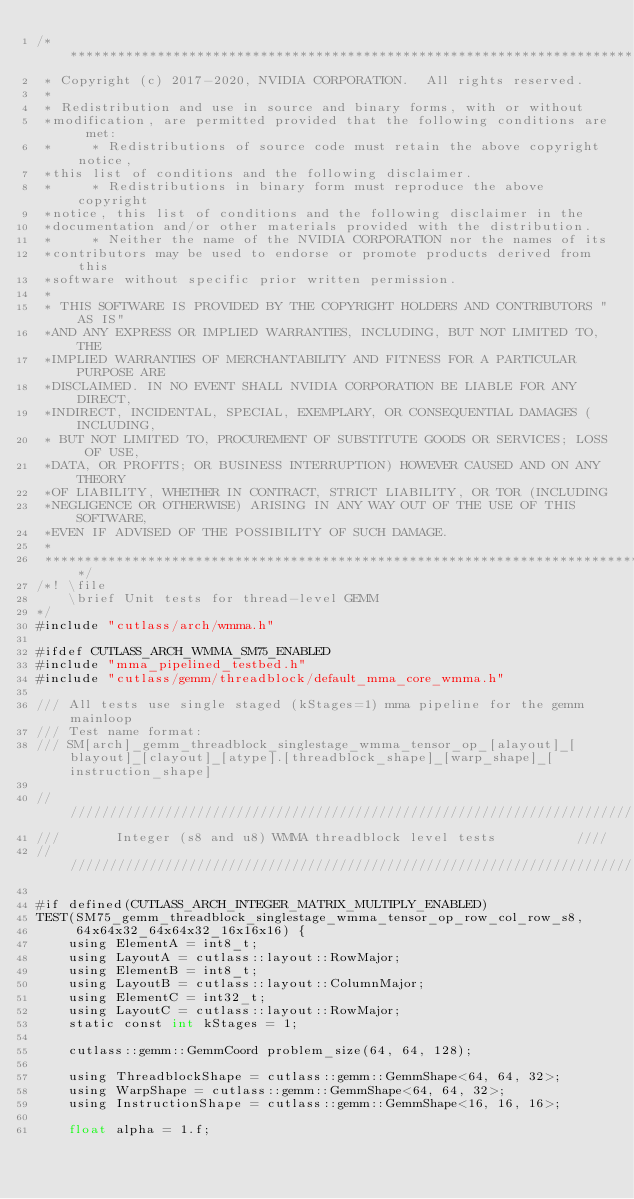Convert code to text. <code><loc_0><loc_0><loc_500><loc_500><_Cuda_>/***************************************************************************************************
 * Copyright (c) 2017-2020, NVIDIA CORPORATION.  All rights reserved.
 *
 * Redistribution and use in source and binary forms, with or without
 *modification, are permitted provided that the following conditions are met:
 *     * Redistributions of source code must retain the above copyright notice,
 *this list of conditions and the following disclaimer.
 *     * Redistributions in binary form must reproduce the above copyright
 *notice, this list of conditions and the following disclaimer in the
 *documentation and/or other materials provided with the distribution.
 *     * Neither the name of the NVIDIA CORPORATION nor the names of its
 *contributors may be used to endorse or promote products derived from this
 *software without specific prior written permission.
 *
 * THIS SOFTWARE IS PROVIDED BY THE COPYRIGHT HOLDERS AND CONTRIBUTORS "AS IS"
 *AND ANY EXPRESS OR IMPLIED WARRANTIES, INCLUDING, BUT NOT LIMITED TO, THE
 *IMPLIED WARRANTIES OF MERCHANTABILITY AND FITNESS FOR A PARTICULAR PURPOSE ARE
 *DISCLAIMED. IN NO EVENT SHALL NVIDIA CORPORATION BE LIABLE FOR ANY DIRECT,
 *INDIRECT, INCIDENTAL, SPECIAL, EXEMPLARY, OR CONSEQUENTIAL DAMAGES (INCLUDING,
 * BUT NOT LIMITED TO, PROCUREMENT OF SUBSTITUTE GOODS OR SERVICES; LOSS OF USE,
 *DATA, OR PROFITS; OR BUSINESS INTERRUPTION) HOWEVER CAUSED AND ON ANY THEORY
 *OF LIABILITY, WHETHER IN CONTRACT, STRICT LIABILITY, OR TOR (INCLUDING
 *NEGLIGENCE OR OTHERWISE) ARISING IN ANY WAY OUT OF THE USE OF THIS SOFTWARE,
 *EVEN IF ADVISED OF THE POSSIBILITY OF SUCH DAMAGE.
 *
 **************************************************************************************************/
/*! \file
    \brief Unit tests for thread-level GEMM
*/
#include "cutlass/arch/wmma.h"

#ifdef CUTLASS_ARCH_WMMA_SM75_ENABLED
#include "mma_pipelined_testbed.h"
#include "cutlass/gemm/threadblock/default_mma_core_wmma.h"

/// All tests use single staged (kStages=1) mma pipeline for the gemm mainloop
/// Test name format:
/// SM[arch]_gemm_threadblock_singlestage_wmma_tensor_op_[alayout]_[blayout]_[clayout]_[atype].[threadblock_shape]_[warp_shape]_[instruction_shape]

/////////////////////////////////////////////////////////////////////////
///       Integer (s8 and u8) WMMA threadblock level tests          ////
/////////////////////////////////////////////////////////////////////////

#if defined(CUTLASS_ARCH_INTEGER_MATRIX_MULTIPLY_ENABLED)
TEST(SM75_gemm_threadblock_singlestage_wmma_tensor_op_row_col_row_s8,
     64x64x32_64x64x32_16x16x16) {
    using ElementA = int8_t;
    using LayoutA = cutlass::layout::RowMajor;
    using ElementB = int8_t;
    using LayoutB = cutlass::layout::ColumnMajor;
    using ElementC = int32_t;
    using LayoutC = cutlass::layout::RowMajor;
    static const int kStages = 1;

    cutlass::gemm::GemmCoord problem_size(64, 64, 128);

    using ThreadblockShape = cutlass::gemm::GemmShape<64, 64, 32>;
    using WarpShape = cutlass::gemm::GemmShape<64, 64, 32>;
    using InstructionShape = cutlass::gemm::GemmShape<16, 16, 16>;

    float alpha = 1.f;</code> 